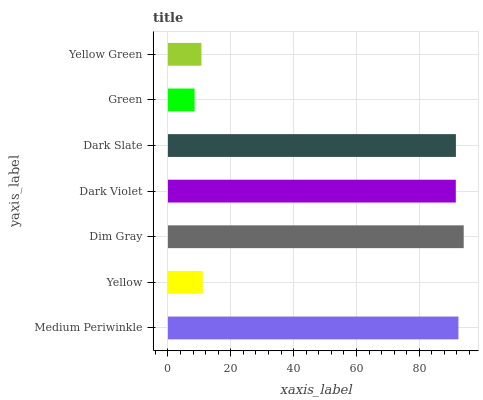Is Green the minimum?
Answer yes or no. Yes. Is Dim Gray the maximum?
Answer yes or no. Yes. Is Yellow the minimum?
Answer yes or no. No. Is Yellow the maximum?
Answer yes or no. No. Is Medium Periwinkle greater than Yellow?
Answer yes or no. Yes. Is Yellow less than Medium Periwinkle?
Answer yes or no. Yes. Is Yellow greater than Medium Periwinkle?
Answer yes or no. No. Is Medium Periwinkle less than Yellow?
Answer yes or no. No. Is Dark Violet the high median?
Answer yes or no. Yes. Is Dark Violet the low median?
Answer yes or no. Yes. Is Dim Gray the high median?
Answer yes or no. No. Is Green the low median?
Answer yes or no. No. 